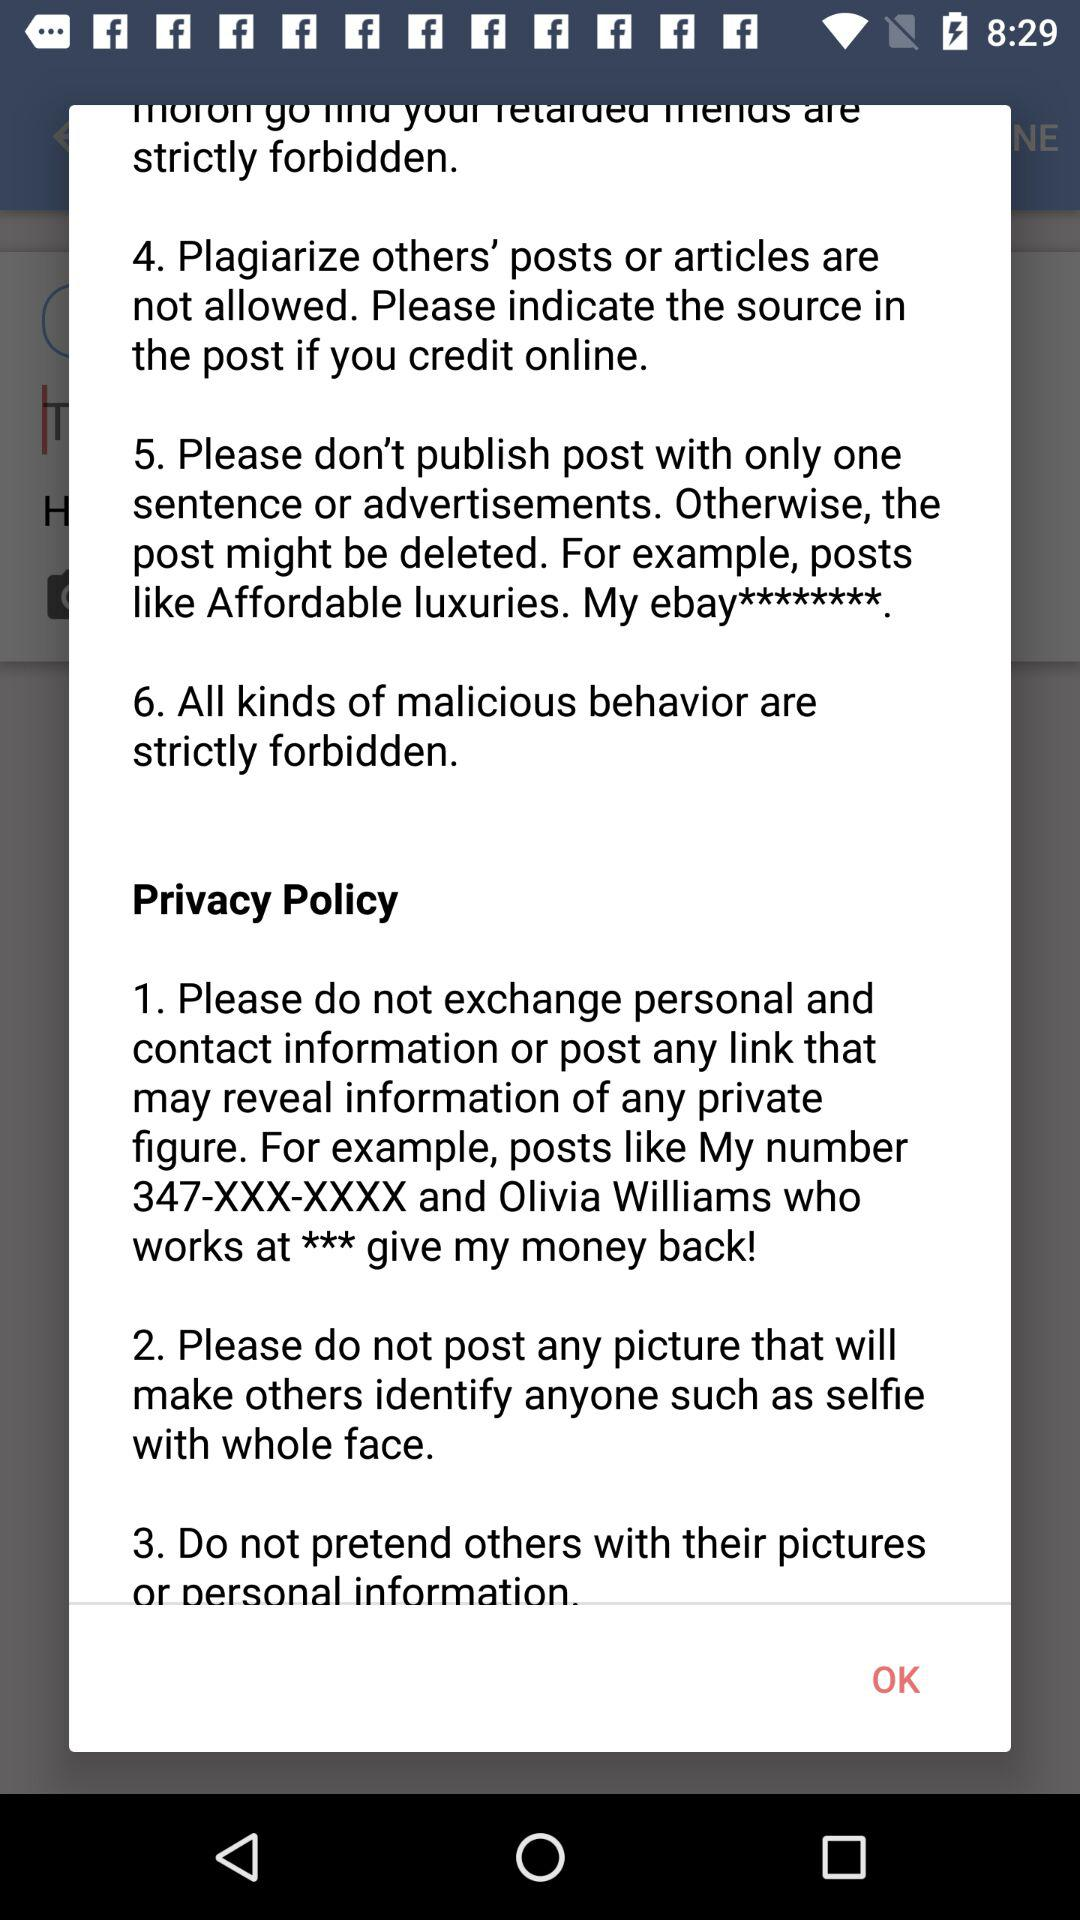How many rules are there on this page?
Answer the question using a single word or phrase. 6 